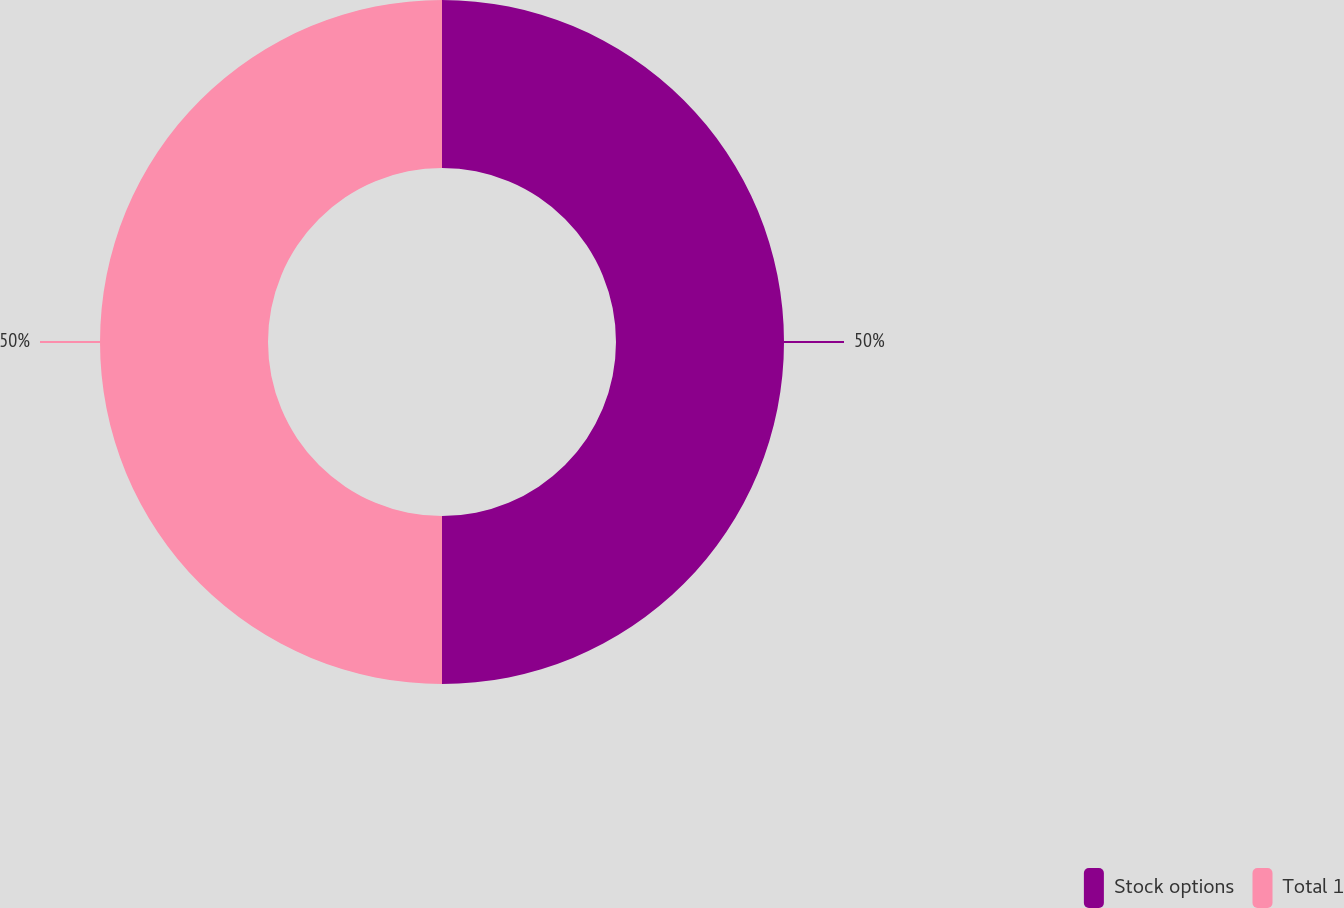<chart> <loc_0><loc_0><loc_500><loc_500><pie_chart><fcel>Stock options<fcel>Total 1<nl><fcel>50.0%<fcel>50.0%<nl></chart> 